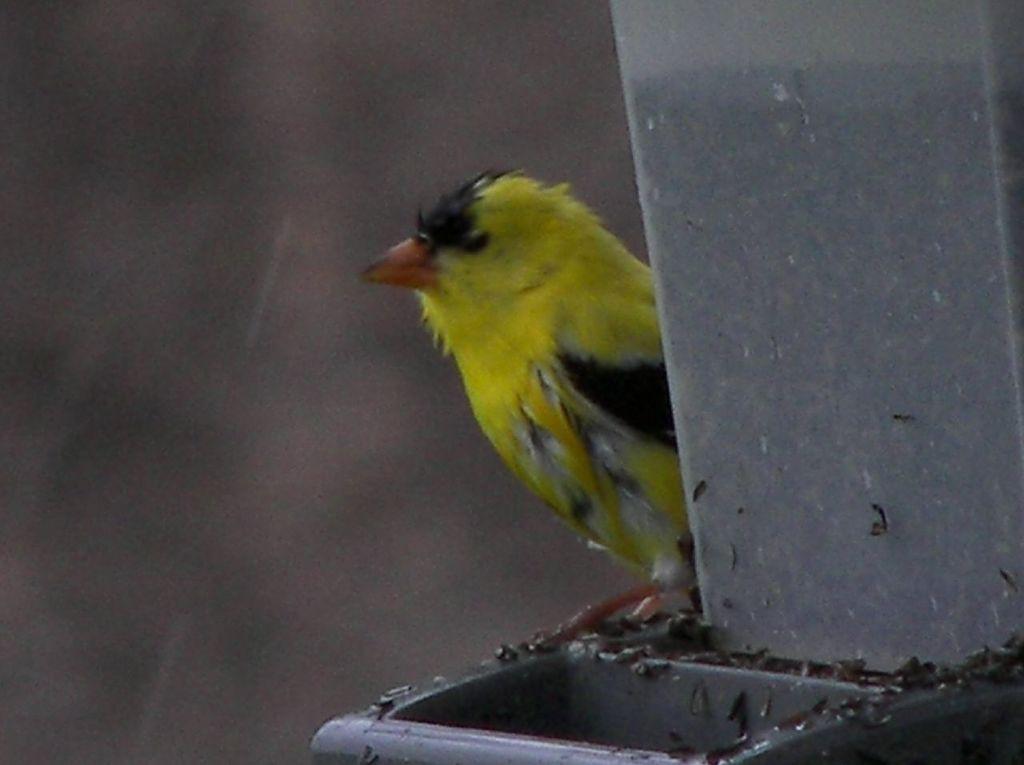Can you describe this image briefly? In this image there is a bird on a pole. 